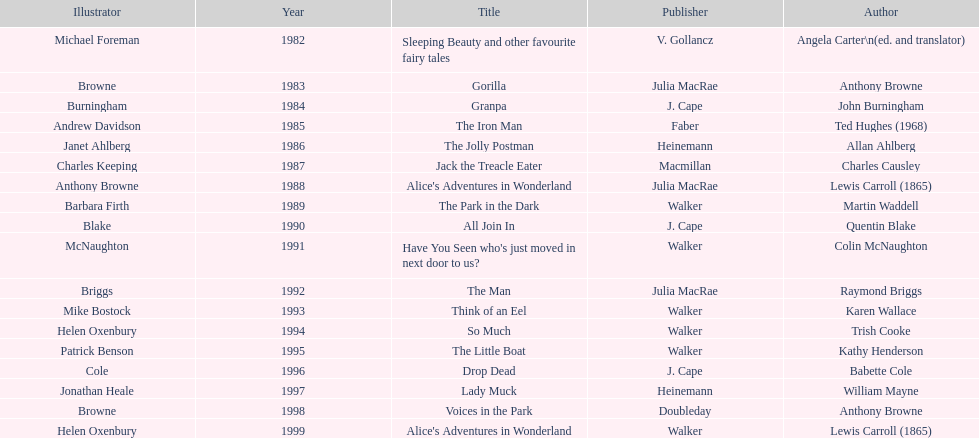Which author wrote the first award winner? Angela Carter. 